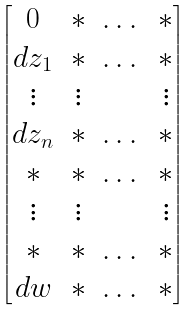Convert formula to latex. <formula><loc_0><loc_0><loc_500><loc_500>\begin{bmatrix} 0 & * & \dots & * \\ d z _ { 1 } & * & \dots & * \\ \vdots & \vdots & \ & \vdots \\ d z _ { n } & * & \dots & * \\ * & * & \dots & * \\ \vdots & \vdots & \ & \vdots \\ * & * & \dots & * \\ d w & * & \dots & * \\ \end{bmatrix}</formula> 